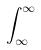Convert formula to latex. <formula><loc_0><loc_0><loc_500><loc_500>\int _ { \infty } ^ { \infty }</formula> 